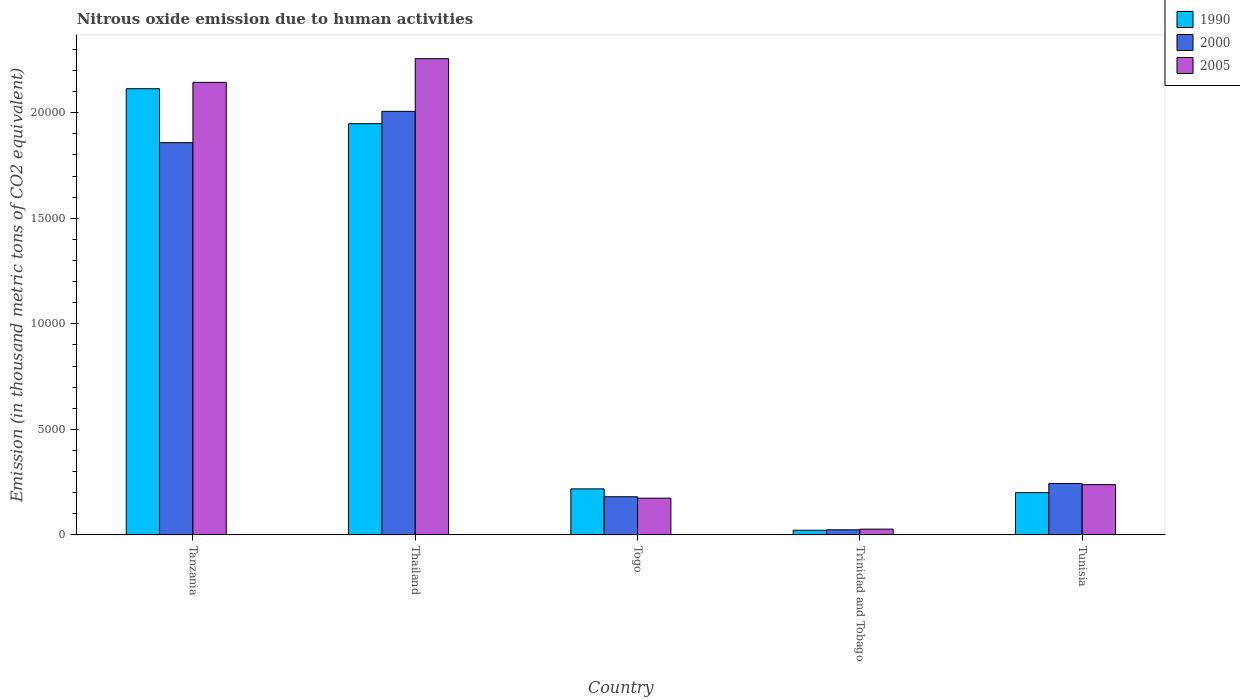How many different coloured bars are there?
Provide a succinct answer. 3. Are the number of bars on each tick of the X-axis equal?
Your response must be concise. Yes. How many bars are there on the 4th tick from the right?
Offer a terse response. 3. What is the label of the 3rd group of bars from the left?
Offer a terse response. Togo. In how many cases, is the number of bars for a given country not equal to the number of legend labels?
Ensure brevity in your answer.  0. What is the amount of nitrous oxide emitted in 1990 in Trinidad and Tobago?
Your answer should be compact. 219.9. Across all countries, what is the maximum amount of nitrous oxide emitted in 2005?
Give a very brief answer. 2.26e+04. Across all countries, what is the minimum amount of nitrous oxide emitted in 2000?
Offer a very short reply. 241.5. In which country was the amount of nitrous oxide emitted in 2005 maximum?
Keep it short and to the point. Thailand. In which country was the amount of nitrous oxide emitted in 2005 minimum?
Make the answer very short. Trinidad and Tobago. What is the total amount of nitrous oxide emitted in 2005 in the graph?
Keep it short and to the point. 4.84e+04. What is the difference between the amount of nitrous oxide emitted in 2000 in Thailand and that in Trinidad and Tobago?
Make the answer very short. 1.98e+04. What is the difference between the amount of nitrous oxide emitted in 2005 in Togo and the amount of nitrous oxide emitted in 1990 in Tanzania?
Make the answer very short. -1.94e+04. What is the average amount of nitrous oxide emitted in 1990 per country?
Ensure brevity in your answer.  9003.52. What is the difference between the amount of nitrous oxide emitted of/in 2000 and amount of nitrous oxide emitted of/in 1990 in Thailand?
Your answer should be very brief. 586.2. What is the ratio of the amount of nitrous oxide emitted in 2000 in Tanzania to that in Trinidad and Tobago?
Offer a terse response. 76.94. Is the difference between the amount of nitrous oxide emitted in 2000 in Thailand and Tunisia greater than the difference between the amount of nitrous oxide emitted in 1990 in Thailand and Tunisia?
Make the answer very short. Yes. What is the difference between the highest and the second highest amount of nitrous oxide emitted in 2005?
Ensure brevity in your answer.  -1.91e+04. What is the difference between the highest and the lowest amount of nitrous oxide emitted in 2000?
Offer a terse response. 1.98e+04. Is the sum of the amount of nitrous oxide emitted in 1990 in Tanzania and Tunisia greater than the maximum amount of nitrous oxide emitted in 2000 across all countries?
Offer a terse response. Yes. What does the 2nd bar from the left in Tanzania represents?
Ensure brevity in your answer.  2000. Is it the case that in every country, the sum of the amount of nitrous oxide emitted in 2000 and amount of nitrous oxide emitted in 1990 is greater than the amount of nitrous oxide emitted in 2005?
Offer a terse response. Yes. How many bars are there?
Make the answer very short. 15. How many countries are there in the graph?
Your answer should be very brief. 5. How many legend labels are there?
Provide a short and direct response. 3. How are the legend labels stacked?
Offer a very short reply. Vertical. What is the title of the graph?
Offer a very short reply. Nitrous oxide emission due to human activities. Does "1972" appear as one of the legend labels in the graph?
Offer a terse response. No. What is the label or title of the X-axis?
Offer a very short reply. Country. What is the label or title of the Y-axis?
Offer a very short reply. Emission (in thousand metric tons of CO2 equivalent). What is the Emission (in thousand metric tons of CO2 equivalent) in 1990 in Tanzania?
Offer a terse response. 2.11e+04. What is the Emission (in thousand metric tons of CO2 equivalent) of 2000 in Tanzania?
Make the answer very short. 1.86e+04. What is the Emission (in thousand metric tons of CO2 equivalent) of 2005 in Tanzania?
Make the answer very short. 2.14e+04. What is the Emission (in thousand metric tons of CO2 equivalent) of 1990 in Thailand?
Offer a very short reply. 1.95e+04. What is the Emission (in thousand metric tons of CO2 equivalent) in 2000 in Thailand?
Your answer should be compact. 2.01e+04. What is the Emission (in thousand metric tons of CO2 equivalent) in 2005 in Thailand?
Your answer should be compact. 2.26e+04. What is the Emission (in thousand metric tons of CO2 equivalent) in 1990 in Togo?
Offer a terse response. 2179.7. What is the Emission (in thousand metric tons of CO2 equivalent) of 2000 in Togo?
Ensure brevity in your answer.  1807. What is the Emission (in thousand metric tons of CO2 equivalent) in 2005 in Togo?
Provide a short and direct response. 1739.7. What is the Emission (in thousand metric tons of CO2 equivalent) of 1990 in Trinidad and Tobago?
Offer a terse response. 219.9. What is the Emission (in thousand metric tons of CO2 equivalent) in 2000 in Trinidad and Tobago?
Keep it short and to the point. 241.5. What is the Emission (in thousand metric tons of CO2 equivalent) in 2005 in Trinidad and Tobago?
Ensure brevity in your answer.  272.8. What is the Emission (in thousand metric tons of CO2 equivalent) of 1990 in Tunisia?
Provide a short and direct response. 2001.7. What is the Emission (in thousand metric tons of CO2 equivalent) of 2000 in Tunisia?
Keep it short and to the point. 2436.9. What is the Emission (in thousand metric tons of CO2 equivalent) in 2005 in Tunisia?
Provide a succinct answer. 2379.7. Across all countries, what is the maximum Emission (in thousand metric tons of CO2 equivalent) in 1990?
Your answer should be very brief. 2.11e+04. Across all countries, what is the maximum Emission (in thousand metric tons of CO2 equivalent) of 2000?
Give a very brief answer. 2.01e+04. Across all countries, what is the maximum Emission (in thousand metric tons of CO2 equivalent) of 2005?
Ensure brevity in your answer.  2.26e+04. Across all countries, what is the minimum Emission (in thousand metric tons of CO2 equivalent) of 1990?
Offer a very short reply. 219.9. Across all countries, what is the minimum Emission (in thousand metric tons of CO2 equivalent) in 2000?
Provide a succinct answer. 241.5. Across all countries, what is the minimum Emission (in thousand metric tons of CO2 equivalent) of 2005?
Give a very brief answer. 272.8. What is the total Emission (in thousand metric tons of CO2 equivalent) of 1990 in the graph?
Provide a short and direct response. 4.50e+04. What is the total Emission (in thousand metric tons of CO2 equivalent) of 2000 in the graph?
Your response must be concise. 4.31e+04. What is the total Emission (in thousand metric tons of CO2 equivalent) in 2005 in the graph?
Your answer should be very brief. 4.84e+04. What is the difference between the Emission (in thousand metric tons of CO2 equivalent) of 1990 in Tanzania and that in Thailand?
Offer a terse response. 1658.1. What is the difference between the Emission (in thousand metric tons of CO2 equivalent) in 2000 in Tanzania and that in Thailand?
Make the answer very short. -1485.1. What is the difference between the Emission (in thousand metric tons of CO2 equivalent) in 2005 in Tanzania and that in Thailand?
Give a very brief answer. -1121.9. What is the difference between the Emission (in thousand metric tons of CO2 equivalent) of 1990 in Tanzania and that in Togo?
Keep it short and to the point. 1.90e+04. What is the difference between the Emission (in thousand metric tons of CO2 equivalent) of 2000 in Tanzania and that in Togo?
Your response must be concise. 1.68e+04. What is the difference between the Emission (in thousand metric tons of CO2 equivalent) in 2005 in Tanzania and that in Togo?
Your answer should be very brief. 1.97e+04. What is the difference between the Emission (in thousand metric tons of CO2 equivalent) of 1990 in Tanzania and that in Trinidad and Tobago?
Ensure brevity in your answer.  2.09e+04. What is the difference between the Emission (in thousand metric tons of CO2 equivalent) of 2000 in Tanzania and that in Trinidad and Tobago?
Make the answer very short. 1.83e+04. What is the difference between the Emission (in thousand metric tons of CO2 equivalent) in 2005 in Tanzania and that in Trinidad and Tobago?
Offer a very short reply. 2.12e+04. What is the difference between the Emission (in thousand metric tons of CO2 equivalent) of 1990 in Tanzania and that in Tunisia?
Your answer should be very brief. 1.91e+04. What is the difference between the Emission (in thousand metric tons of CO2 equivalent) of 2000 in Tanzania and that in Tunisia?
Your answer should be compact. 1.61e+04. What is the difference between the Emission (in thousand metric tons of CO2 equivalent) of 2005 in Tanzania and that in Tunisia?
Ensure brevity in your answer.  1.91e+04. What is the difference between the Emission (in thousand metric tons of CO2 equivalent) in 1990 in Thailand and that in Togo?
Make the answer very short. 1.73e+04. What is the difference between the Emission (in thousand metric tons of CO2 equivalent) of 2000 in Thailand and that in Togo?
Your response must be concise. 1.83e+04. What is the difference between the Emission (in thousand metric tons of CO2 equivalent) of 2005 in Thailand and that in Togo?
Keep it short and to the point. 2.08e+04. What is the difference between the Emission (in thousand metric tons of CO2 equivalent) of 1990 in Thailand and that in Trinidad and Tobago?
Offer a terse response. 1.93e+04. What is the difference between the Emission (in thousand metric tons of CO2 equivalent) of 2000 in Thailand and that in Trinidad and Tobago?
Offer a terse response. 1.98e+04. What is the difference between the Emission (in thousand metric tons of CO2 equivalent) in 2005 in Thailand and that in Trinidad and Tobago?
Offer a very short reply. 2.23e+04. What is the difference between the Emission (in thousand metric tons of CO2 equivalent) of 1990 in Thailand and that in Tunisia?
Provide a succinct answer. 1.75e+04. What is the difference between the Emission (in thousand metric tons of CO2 equivalent) of 2000 in Thailand and that in Tunisia?
Keep it short and to the point. 1.76e+04. What is the difference between the Emission (in thousand metric tons of CO2 equivalent) in 2005 in Thailand and that in Tunisia?
Your answer should be compact. 2.02e+04. What is the difference between the Emission (in thousand metric tons of CO2 equivalent) in 1990 in Togo and that in Trinidad and Tobago?
Offer a terse response. 1959.8. What is the difference between the Emission (in thousand metric tons of CO2 equivalent) in 2000 in Togo and that in Trinidad and Tobago?
Provide a succinct answer. 1565.5. What is the difference between the Emission (in thousand metric tons of CO2 equivalent) of 2005 in Togo and that in Trinidad and Tobago?
Your response must be concise. 1466.9. What is the difference between the Emission (in thousand metric tons of CO2 equivalent) in 1990 in Togo and that in Tunisia?
Your answer should be compact. 178. What is the difference between the Emission (in thousand metric tons of CO2 equivalent) of 2000 in Togo and that in Tunisia?
Your response must be concise. -629.9. What is the difference between the Emission (in thousand metric tons of CO2 equivalent) of 2005 in Togo and that in Tunisia?
Ensure brevity in your answer.  -640. What is the difference between the Emission (in thousand metric tons of CO2 equivalent) of 1990 in Trinidad and Tobago and that in Tunisia?
Your answer should be compact. -1781.8. What is the difference between the Emission (in thousand metric tons of CO2 equivalent) of 2000 in Trinidad and Tobago and that in Tunisia?
Make the answer very short. -2195.4. What is the difference between the Emission (in thousand metric tons of CO2 equivalent) of 2005 in Trinidad and Tobago and that in Tunisia?
Your answer should be very brief. -2106.9. What is the difference between the Emission (in thousand metric tons of CO2 equivalent) in 1990 in Tanzania and the Emission (in thousand metric tons of CO2 equivalent) in 2000 in Thailand?
Give a very brief answer. 1071.9. What is the difference between the Emission (in thousand metric tons of CO2 equivalent) of 1990 in Tanzania and the Emission (in thousand metric tons of CO2 equivalent) of 2005 in Thailand?
Make the answer very short. -1422.1. What is the difference between the Emission (in thousand metric tons of CO2 equivalent) of 2000 in Tanzania and the Emission (in thousand metric tons of CO2 equivalent) of 2005 in Thailand?
Give a very brief answer. -3979.1. What is the difference between the Emission (in thousand metric tons of CO2 equivalent) of 1990 in Tanzania and the Emission (in thousand metric tons of CO2 equivalent) of 2000 in Togo?
Offer a very short reply. 1.93e+04. What is the difference between the Emission (in thousand metric tons of CO2 equivalent) in 1990 in Tanzania and the Emission (in thousand metric tons of CO2 equivalent) in 2005 in Togo?
Ensure brevity in your answer.  1.94e+04. What is the difference between the Emission (in thousand metric tons of CO2 equivalent) of 2000 in Tanzania and the Emission (in thousand metric tons of CO2 equivalent) of 2005 in Togo?
Ensure brevity in your answer.  1.68e+04. What is the difference between the Emission (in thousand metric tons of CO2 equivalent) in 1990 in Tanzania and the Emission (in thousand metric tons of CO2 equivalent) in 2000 in Trinidad and Tobago?
Your response must be concise. 2.09e+04. What is the difference between the Emission (in thousand metric tons of CO2 equivalent) in 1990 in Tanzania and the Emission (in thousand metric tons of CO2 equivalent) in 2005 in Trinidad and Tobago?
Give a very brief answer. 2.09e+04. What is the difference between the Emission (in thousand metric tons of CO2 equivalent) in 2000 in Tanzania and the Emission (in thousand metric tons of CO2 equivalent) in 2005 in Trinidad and Tobago?
Give a very brief answer. 1.83e+04. What is the difference between the Emission (in thousand metric tons of CO2 equivalent) in 1990 in Tanzania and the Emission (in thousand metric tons of CO2 equivalent) in 2000 in Tunisia?
Your answer should be very brief. 1.87e+04. What is the difference between the Emission (in thousand metric tons of CO2 equivalent) of 1990 in Tanzania and the Emission (in thousand metric tons of CO2 equivalent) of 2005 in Tunisia?
Make the answer very short. 1.88e+04. What is the difference between the Emission (in thousand metric tons of CO2 equivalent) in 2000 in Tanzania and the Emission (in thousand metric tons of CO2 equivalent) in 2005 in Tunisia?
Keep it short and to the point. 1.62e+04. What is the difference between the Emission (in thousand metric tons of CO2 equivalent) of 1990 in Thailand and the Emission (in thousand metric tons of CO2 equivalent) of 2000 in Togo?
Make the answer very short. 1.77e+04. What is the difference between the Emission (in thousand metric tons of CO2 equivalent) of 1990 in Thailand and the Emission (in thousand metric tons of CO2 equivalent) of 2005 in Togo?
Your response must be concise. 1.77e+04. What is the difference between the Emission (in thousand metric tons of CO2 equivalent) in 2000 in Thailand and the Emission (in thousand metric tons of CO2 equivalent) in 2005 in Togo?
Provide a succinct answer. 1.83e+04. What is the difference between the Emission (in thousand metric tons of CO2 equivalent) in 1990 in Thailand and the Emission (in thousand metric tons of CO2 equivalent) in 2000 in Trinidad and Tobago?
Your response must be concise. 1.92e+04. What is the difference between the Emission (in thousand metric tons of CO2 equivalent) of 1990 in Thailand and the Emission (in thousand metric tons of CO2 equivalent) of 2005 in Trinidad and Tobago?
Offer a very short reply. 1.92e+04. What is the difference between the Emission (in thousand metric tons of CO2 equivalent) in 2000 in Thailand and the Emission (in thousand metric tons of CO2 equivalent) in 2005 in Trinidad and Tobago?
Ensure brevity in your answer.  1.98e+04. What is the difference between the Emission (in thousand metric tons of CO2 equivalent) in 1990 in Thailand and the Emission (in thousand metric tons of CO2 equivalent) in 2000 in Tunisia?
Keep it short and to the point. 1.70e+04. What is the difference between the Emission (in thousand metric tons of CO2 equivalent) of 1990 in Thailand and the Emission (in thousand metric tons of CO2 equivalent) of 2005 in Tunisia?
Your answer should be very brief. 1.71e+04. What is the difference between the Emission (in thousand metric tons of CO2 equivalent) in 2000 in Thailand and the Emission (in thousand metric tons of CO2 equivalent) in 2005 in Tunisia?
Your answer should be compact. 1.77e+04. What is the difference between the Emission (in thousand metric tons of CO2 equivalent) in 1990 in Togo and the Emission (in thousand metric tons of CO2 equivalent) in 2000 in Trinidad and Tobago?
Offer a very short reply. 1938.2. What is the difference between the Emission (in thousand metric tons of CO2 equivalent) in 1990 in Togo and the Emission (in thousand metric tons of CO2 equivalent) in 2005 in Trinidad and Tobago?
Keep it short and to the point. 1906.9. What is the difference between the Emission (in thousand metric tons of CO2 equivalent) in 2000 in Togo and the Emission (in thousand metric tons of CO2 equivalent) in 2005 in Trinidad and Tobago?
Offer a very short reply. 1534.2. What is the difference between the Emission (in thousand metric tons of CO2 equivalent) of 1990 in Togo and the Emission (in thousand metric tons of CO2 equivalent) of 2000 in Tunisia?
Provide a succinct answer. -257.2. What is the difference between the Emission (in thousand metric tons of CO2 equivalent) in 1990 in Togo and the Emission (in thousand metric tons of CO2 equivalent) in 2005 in Tunisia?
Keep it short and to the point. -200. What is the difference between the Emission (in thousand metric tons of CO2 equivalent) in 2000 in Togo and the Emission (in thousand metric tons of CO2 equivalent) in 2005 in Tunisia?
Offer a terse response. -572.7. What is the difference between the Emission (in thousand metric tons of CO2 equivalent) in 1990 in Trinidad and Tobago and the Emission (in thousand metric tons of CO2 equivalent) in 2000 in Tunisia?
Ensure brevity in your answer.  -2217. What is the difference between the Emission (in thousand metric tons of CO2 equivalent) in 1990 in Trinidad and Tobago and the Emission (in thousand metric tons of CO2 equivalent) in 2005 in Tunisia?
Make the answer very short. -2159.8. What is the difference between the Emission (in thousand metric tons of CO2 equivalent) of 2000 in Trinidad and Tobago and the Emission (in thousand metric tons of CO2 equivalent) of 2005 in Tunisia?
Your response must be concise. -2138.2. What is the average Emission (in thousand metric tons of CO2 equivalent) in 1990 per country?
Make the answer very short. 9003.52. What is the average Emission (in thousand metric tons of CO2 equivalent) in 2000 per country?
Provide a succinct answer. 8626.18. What is the average Emission (in thousand metric tons of CO2 equivalent) of 2005 per country?
Offer a terse response. 9677.78. What is the difference between the Emission (in thousand metric tons of CO2 equivalent) in 1990 and Emission (in thousand metric tons of CO2 equivalent) in 2000 in Tanzania?
Provide a succinct answer. 2557. What is the difference between the Emission (in thousand metric tons of CO2 equivalent) in 1990 and Emission (in thousand metric tons of CO2 equivalent) in 2005 in Tanzania?
Give a very brief answer. -300.2. What is the difference between the Emission (in thousand metric tons of CO2 equivalent) in 2000 and Emission (in thousand metric tons of CO2 equivalent) in 2005 in Tanzania?
Your answer should be very brief. -2857.2. What is the difference between the Emission (in thousand metric tons of CO2 equivalent) in 1990 and Emission (in thousand metric tons of CO2 equivalent) in 2000 in Thailand?
Give a very brief answer. -586.2. What is the difference between the Emission (in thousand metric tons of CO2 equivalent) of 1990 and Emission (in thousand metric tons of CO2 equivalent) of 2005 in Thailand?
Offer a terse response. -3080.2. What is the difference between the Emission (in thousand metric tons of CO2 equivalent) of 2000 and Emission (in thousand metric tons of CO2 equivalent) of 2005 in Thailand?
Ensure brevity in your answer.  -2494. What is the difference between the Emission (in thousand metric tons of CO2 equivalent) of 1990 and Emission (in thousand metric tons of CO2 equivalent) of 2000 in Togo?
Give a very brief answer. 372.7. What is the difference between the Emission (in thousand metric tons of CO2 equivalent) in 1990 and Emission (in thousand metric tons of CO2 equivalent) in 2005 in Togo?
Keep it short and to the point. 440. What is the difference between the Emission (in thousand metric tons of CO2 equivalent) in 2000 and Emission (in thousand metric tons of CO2 equivalent) in 2005 in Togo?
Provide a short and direct response. 67.3. What is the difference between the Emission (in thousand metric tons of CO2 equivalent) of 1990 and Emission (in thousand metric tons of CO2 equivalent) of 2000 in Trinidad and Tobago?
Your response must be concise. -21.6. What is the difference between the Emission (in thousand metric tons of CO2 equivalent) of 1990 and Emission (in thousand metric tons of CO2 equivalent) of 2005 in Trinidad and Tobago?
Provide a short and direct response. -52.9. What is the difference between the Emission (in thousand metric tons of CO2 equivalent) in 2000 and Emission (in thousand metric tons of CO2 equivalent) in 2005 in Trinidad and Tobago?
Your response must be concise. -31.3. What is the difference between the Emission (in thousand metric tons of CO2 equivalent) of 1990 and Emission (in thousand metric tons of CO2 equivalent) of 2000 in Tunisia?
Offer a terse response. -435.2. What is the difference between the Emission (in thousand metric tons of CO2 equivalent) in 1990 and Emission (in thousand metric tons of CO2 equivalent) in 2005 in Tunisia?
Ensure brevity in your answer.  -378. What is the difference between the Emission (in thousand metric tons of CO2 equivalent) of 2000 and Emission (in thousand metric tons of CO2 equivalent) of 2005 in Tunisia?
Make the answer very short. 57.2. What is the ratio of the Emission (in thousand metric tons of CO2 equivalent) of 1990 in Tanzania to that in Thailand?
Your response must be concise. 1.09. What is the ratio of the Emission (in thousand metric tons of CO2 equivalent) in 2000 in Tanzania to that in Thailand?
Offer a terse response. 0.93. What is the ratio of the Emission (in thousand metric tons of CO2 equivalent) of 2005 in Tanzania to that in Thailand?
Your response must be concise. 0.95. What is the ratio of the Emission (in thousand metric tons of CO2 equivalent) in 1990 in Tanzania to that in Togo?
Provide a short and direct response. 9.7. What is the ratio of the Emission (in thousand metric tons of CO2 equivalent) of 2000 in Tanzania to that in Togo?
Offer a very short reply. 10.28. What is the ratio of the Emission (in thousand metric tons of CO2 equivalent) in 2005 in Tanzania to that in Togo?
Make the answer very short. 12.32. What is the ratio of the Emission (in thousand metric tons of CO2 equivalent) of 1990 in Tanzania to that in Trinidad and Tobago?
Your response must be concise. 96.12. What is the ratio of the Emission (in thousand metric tons of CO2 equivalent) of 2000 in Tanzania to that in Trinidad and Tobago?
Make the answer very short. 76.94. What is the ratio of the Emission (in thousand metric tons of CO2 equivalent) of 2005 in Tanzania to that in Trinidad and Tobago?
Provide a short and direct response. 78.58. What is the ratio of the Emission (in thousand metric tons of CO2 equivalent) in 1990 in Tanzania to that in Tunisia?
Offer a very short reply. 10.56. What is the ratio of the Emission (in thousand metric tons of CO2 equivalent) in 2000 in Tanzania to that in Tunisia?
Provide a short and direct response. 7.62. What is the ratio of the Emission (in thousand metric tons of CO2 equivalent) in 2005 in Tanzania to that in Tunisia?
Your answer should be very brief. 9.01. What is the ratio of the Emission (in thousand metric tons of CO2 equivalent) of 1990 in Thailand to that in Togo?
Ensure brevity in your answer.  8.94. What is the ratio of the Emission (in thousand metric tons of CO2 equivalent) of 2000 in Thailand to that in Togo?
Offer a very short reply. 11.1. What is the ratio of the Emission (in thousand metric tons of CO2 equivalent) in 2005 in Thailand to that in Togo?
Give a very brief answer. 12.97. What is the ratio of the Emission (in thousand metric tons of CO2 equivalent) in 1990 in Thailand to that in Trinidad and Tobago?
Offer a terse response. 88.58. What is the ratio of the Emission (in thousand metric tons of CO2 equivalent) of 2000 in Thailand to that in Trinidad and Tobago?
Offer a terse response. 83.09. What is the ratio of the Emission (in thousand metric tons of CO2 equivalent) in 2005 in Thailand to that in Trinidad and Tobago?
Offer a terse response. 82.7. What is the ratio of the Emission (in thousand metric tons of CO2 equivalent) in 1990 in Thailand to that in Tunisia?
Provide a short and direct response. 9.73. What is the ratio of the Emission (in thousand metric tons of CO2 equivalent) of 2000 in Thailand to that in Tunisia?
Offer a terse response. 8.23. What is the ratio of the Emission (in thousand metric tons of CO2 equivalent) in 2005 in Thailand to that in Tunisia?
Keep it short and to the point. 9.48. What is the ratio of the Emission (in thousand metric tons of CO2 equivalent) in 1990 in Togo to that in Trinidad and Tobago?
Provide a short and direct response. 9.91. What is the ratio of the Emission (in thousand metric tons of CO2 equivalent) of 2000 in Togo to that in Trinidad and Tobago?
Your answer should be very brief. 7.48. What is the ratio of the Emission (in thousand metric tons of CO2 equivalent) in 2005 in Togo to that in Trinidad and Tobago?
Provide a succinct answer. 6.38. What is the ratio of the Emission (in thousand metric tons of CO2 equivalent) in 1990 in Togo to that in Tunisia?
Offer a terse response. 1.09. What is the ratio of the Emission (in thousand metric tons of CO2 equivalent) in 2000 in Togo to that in Tunisia?
Offer a terse response. 0.74. What is the ratio of the Emission (in thousand metric tons of CO2 equivalent) in 2005 in Togo to that in Tunisia?
Your answer should be very brief. 0.73. What is the ratio of the Emission (in thousand metric tons of CO2 equivalent) in 1990 in Trinidad and Tobago to that in Tunisia?
Offer a terse response. 0.11. What is the ratio of the Emission (in thousand metric tons of CO2 equivalent) of 2000 in Trinidad and Tobago to that in Tunisia?
Your answer should be very brief. 0.1. What is the ratio of the Emission (in thousand metric tons of CO2 equivalent) in 2005 in Trinidad and Tobago to that in Tunisia?
Your response must be concise. 0.11. What is the difference between the highest and the second highest Emission (in thousand metric tons of CO2 equivalent) of 1990?
Ensure brevity in your answer.  1658.1. What is the difference between the highest and the second highest Emission (in thousand metric tons of CO2 equivalent) in 2000?
Provide a short and direct response. 1485.1. What is the difference between the highest and the second highest Emission (in thousand metric tons of CO2 equivalent) in 2005?
Offer a very short reply. 1121.9. What is the difference between the highest and the lowest Emission (in thousand metric tons of CO2 equivalent) of 1990?
Offer a very short reply. 2.09e+04. What is the difference between the highest and the lowest Emission (in thousand metric tons of CO2 equivalent) in 2000?
Your answer should be compact. 1.98e+04. What is the difference between the highest and the lowest Emission (in thousand metric tons of CO2 equivalent) of 2005?
Offer a very short reply. 2.23e+04. 